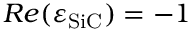Convert formula to latex. <formula><loc_0><loc_0><loc_500><loc_500>R e ( \varepsilon _ { S i C } ) = - 1</formula> 